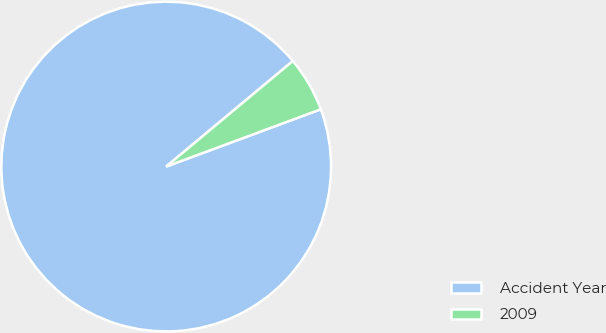Convert chart to OTSL. <chart><loc_0><loc_0><loc_500><loc_500><pie_chart><fcel>Accident Year<fcel>2009<nl><fcel>94.59%<fcel>5.41%<nl></chart> 